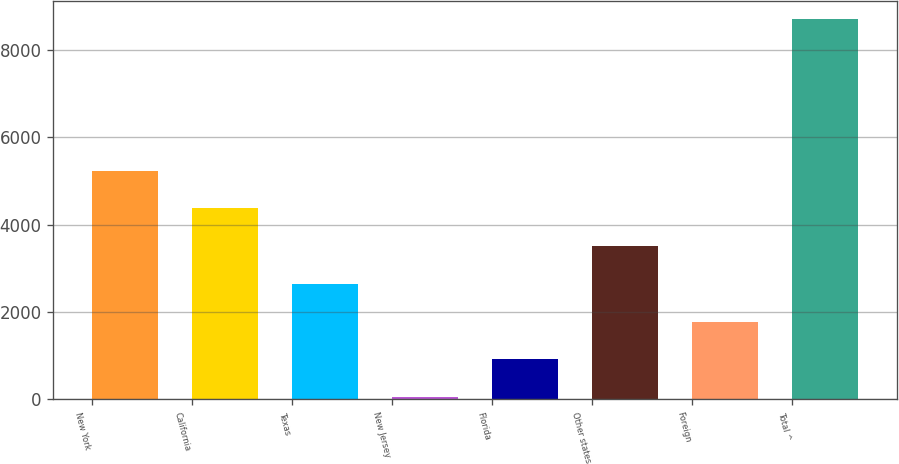Convert chart to OTSL. <chart><loc_0><loc_0><loc_500><loc_500><bar_chart><fcel>New York<fcel>California<fcel>Texas<fcel>New Jersey<fcel>Florida<fcel>Other states<fcel>Foreign<fcel>Total ^<nl><fcel>5238.4<fcel>4373<fcel>2642.2<fcel>46<fcel>911.4<fcel>3507.6<fcel>1776.8<fcel>8700<nl></chart> 